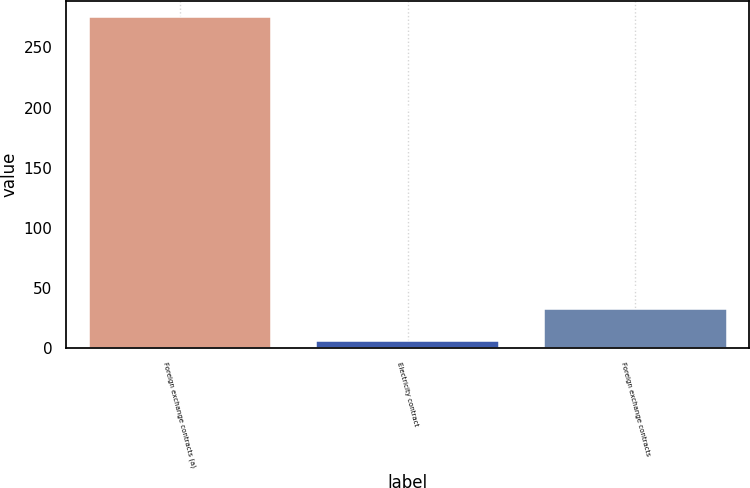Convert chart to OTSL. <chart><loc_0><loc_0><loc_500><loc_500><bar_chart><fcel>Foreign exchange contracts (a)<fcel>Electricity contract<fcel>Foreign exchange contracts<nl><fcel>275<fcel>6<fcel>32.9<nl></chart> 